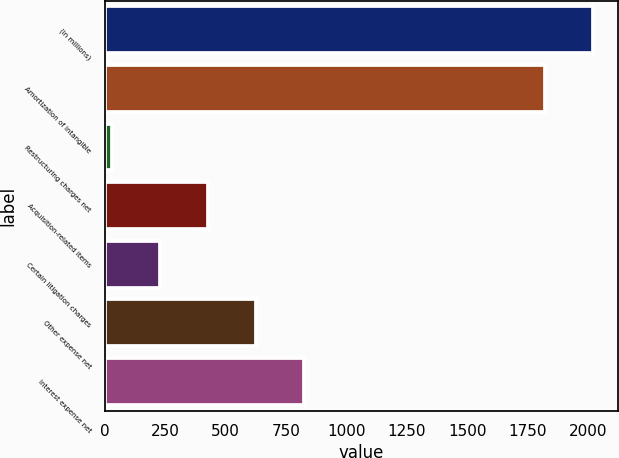Convert chart to OTSL. <chart><loc_0><loc_0><loc_500><loc_500><bar_chart><fcel>(in millions)<fcel>Amortization of intangible<fcel>Restructuring charges net<fcel>Acquisition-related items<fcel>Certain litigation charges<fcel>Other expense net<fcel>Interest expense net<nl><fcel>2021.8<fcel>1823<fcel>30<fcel>427.6<fcel>228.8<fcel>626.4<fcel>825.2<nl></chart> 